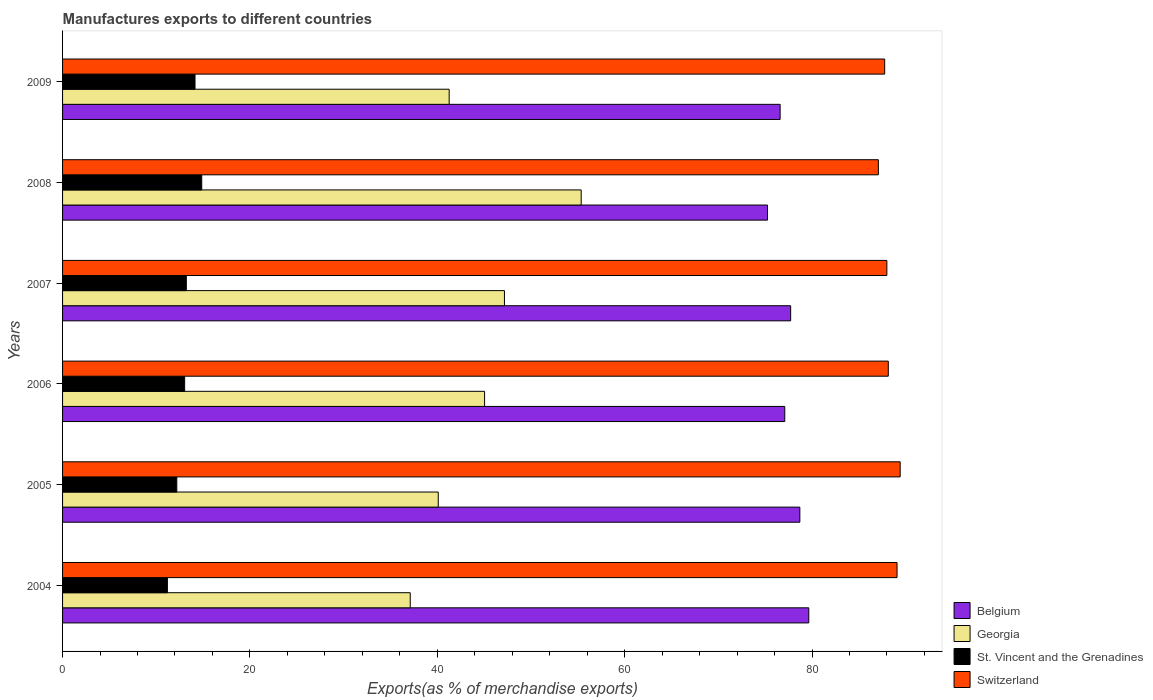How many different coloured bars are there?
Offer a terse response. 4. Are the number of bars on each tick of the Y-axis equal?
Offer a very short reply. Yes. How many bars are there on the 3rd tick from the bottom?
Provide a succinct answer. 4. What is the label of the 6th group of bars from the top?
Provide a short and direct response. 2004. What is the percentage of exports to different countries in St. Vincent and the Grenadines in 2005?
Ensure brevity in your answer.  12.19. Across all years, what is the maximum percentage of exports to different countries in Belgium?
Keep it short and to the point. 79.65. Across all years, what is the minimum percentage of exports to different countries in St. Vincent and the Grenadines?
Provide a succinct answer. 11.19. In which year was the percentage of exports to different countries in Georgia maximum?
Offer a very short reply. 2008. In which year was the percentage of exports to different countries in Georgia minimum?
Keep it short and to the point. 2004. What is the total percentage of exports to different countries in Georgia in the graph?
Give a very brief answer. 266.05. What is the difference between the percentage of exports to different countries in Georgia in 2006 and that in 2009?
Give a very brief answer. 3.78. What is the difference between the percentage of exports to different countries in Switzerland in 2006 and the percentage of exports to different countries in St. Vincent and the Grenadines in 2005?
Offer a terse response. 75.95. What is the average percentage of exports to different countries in Georgia per year?
Offer a terse response. 44.34. In the year 2009, what is the difference between the percentage of exports to different countries in Belgium and percentage of exports to different countries in Georgia?
Make the answer very short. 35.33. What is the ratio of the percentage of exports to different countries in Georgia in 2005 to that in 2009?
Keep it short and to the point. 0.97. Is the percentage of exports to different countries in Georgia in 2005 less than that in 2009?
Keep it short and to the point. Yes. What is the difference between the highest and the second highest percentage of exports to different countries in Belgium?
Make the answer very short. 0.95. What is the difference between the highest and the lowest percentage of exports to different countries in St. Vincent and the Grenadines?
Offer a very short reply. 3.67. Is it the case that in every year, the sum of the percentage of exports to different countries in Switzerland and percentage of exports to different countries in Georgia is greater than the sum of percentage of exports to different countries in St. Vincent and the Grenadines and percentage of exports to different countries in Belgium?
Keep it short and to the point. Yes. What does the 1st bar from the top in 2009 represents?
Your response must be concise. Switzerland. What does the 3rd bar from the bottom in 2006 represents?
Your response must be concise. St. Vincent and the Grenadines. Is it the case that in every year, the sum of the percentage of exports to different countries in Georgia and percentage of exports to different countries in Belgium is greater than the percentage of exports to different countries in St. Vincent and the Grenadines?
Give a very brief answer. Yes. How many bars are there?
Your response must be concise. 24. Are all the bars in the graph horizontal?
Offer a terse response. Yes. How many years are there in the graph?
Your answer should be very brief. 6. Does the graph contain grids?
Provide a succinct answer. No. What is the title of the graph?
Your answer should be compact. Manufactures exports to different countries. What is the label or title of the X-axis?
Give a very brief answer. Exports(as % of merchandise exports). What is the label or title of the Y-axis?
Your answer should be very brief. Years. What is the Exports(as % of merchandise exports) of Belgium in 2004?
Keep it short and to the point. 79.65. What is the Exports(as % of merchandise exports) of Georgia in 2004?
Ensure brevity in your answer.  37.11. What is the Exports(as % of merchandise exports) in St. Vincent and the Grenadines in 2004?
Your answer should be compact. 11.19. What is the Exports(as % of merchandise exports) in Switzerland in 2004?
Your answer should be compact. 89.07. What is the Exports(as % of merchandise exports) of Belgium in 2005?
Your answer should be very brief. 78.7. What is the Exports(as % of merchandise exports) in Georgia in 2005?
Your response must be concise. 40.1. What is the Exports(as % of merchandise exports) in St. Vincent and the Grenadines in 2005?
Your answer should be compact. 12.19. What is the Exports(as % of merchandise exports) in Switzerland in 2005?
Provide a short and direct response. 89.41. What is the Exports(as % of merchandise exports) in Belgium in 2006?
Your answer should be very brief. 77.09. What is the Exports(as % of merchandise exports) of Georgia in 2006?
Offer a terse response. 45.05. What is the Exports(as % of merchandise exports) in St. Vincent and the Grenadines in 2006?
Ensure brevity in your answer.  13.03. What is the Exports(as % of merchandise exports) of Switzerland in 2006?
Keep it short and to the point. 88.14. What is the Exports(as % of merchandise exports) of Belgium in 2007?
Offer a very short reply. 77.72. What is the Exports(as % of merchandise exports) in Georgia in 2007?
Offer a very short reply. 47.17. What is the Exports(as % of merchandise exports) in St. Vincent and the Grenadines in 2007?
Give a very brief answer. 13.21. What is the Exports(as % of merchandise exports) in Switzerland in 2007?
Provide a short and direct response. 87.99. What is the Exports(as % of merchandise exports) of Belgium in 2008?
Make the answer very short. 75.25. What is the Exports(as % of merchandise exports) in Georgia in 2008?
Keep it short and to the point. 55.36. What is the Exports(as % of merchandise exports) in St. Vincent and the Grenadines in 2008?
Your answer should be compact. 14.85. What is the Exports(as % of merchandise exports) in Switzerland in 2008?
Your answer should be compact. 87.08. What is the Exports(as % of merchandise exports) of Belgium in 2009?
Your answer should be compact. 76.59. What is the Exports(as % of merchandise exports) of Georgia in 2009?
Your response must be concise. 41.27. What is the Exports(as % of merchandise exports) of St. Vincent and the Grenadines in 2009?
Keep it short and to the point. 14.14. What is the Exports(as % of merchandise exports) in Switzerland in 2009?
Provide a succinct answer. 87.75. Across all years, what is the maximum Exports(as % of merchandise exports) of Belgium?
Offer a very short reply. 79.65. Across all years, what is the maximum Exports(as % of merchandise exports) of Georgia?
Your response must be concise. 55.36. Across all years, what is the maximum Exports(as % of merchandise exports) in St. Vincent and the Grenadines?
Keep it short and to the point. 14.85. Across all years, what is the maximum Exports(as % of merchandise exports) of Switzerland?
Offer a terse response. 89.41. Across all years, what is the minimum Exports(as % of merchandise exports) in Belgium?
Your response must be concise. 75.25. Across all years, what is the minimum Exports(as % of merchandise exports) of Georgia?
Offer a terse response. 37.11. Across all years, what is the minimum Exports(as % of merchandise exports) of St. Vincent and the Grenadines?
Offer a very short reply. 11.19. Across all years, what is the minimum Exports(as % of merchandise exports) of Switzerland?
Make the answer very short. 87.08. What is the total Exports(as % of merchandise exports) in Belgium in the graph?
Your response must be concise. 465. What is the total Exports(as % of merchandise exports) in Georgia in the graph?
Provide a short and direct response. 266.05. What is the total Exports(as % of merchandise exports) of St. Vincent and the Grenadines in the graph?
Make the answer very short. 78.62. What is the total Exports(as % of merchandise exports) in Switzerland in the graph?
Give a very brief answer. 529.44. What is the difference between the Exports(as % of merchandise exports) of Belgium in 2004 and that in 2005?
Provide a succinct answer. 0.95. What is the difference between the Exports(as % of merchandise exports) of Georgia in 2004 and that in 2005?
Keep it short and to the point. -2.99. What is the difference between the Exports(as % of merchandise exports) in St. Vincent and the Grenadines in 2004 and that in 2005?
Provide a succinct answer. -1. What is the difference between the Exports(as % of merchandise exports) of Switzerland in 2004 and that in 2005?
Offer a terse response. -0.33. What is the difference between the Exports(as % of merchandise exports) of Belgium in 2004 and that in 2006?
Offer a very short reply. 2.56. What is the difference between the Exports(as % of merchandise exports) in Georgia in 2004 and that in 2006?
Make the answer very short. -7.94. What is the difference between the Exports(as % of merchandise exports) of St. Vincent and the Grenadines in 2004 and that in 2006?
Your response must be concise. -1.84. What is the difference between the Exports(as % of merchandise exports) of Switzerland in 2004 and that in 2006?
Provide a short and direct response. 0.93. What is the difference between the Exports(as % of merchandise exports) in Belgium in 2004 and that in 2007?
Your answer should be compact. 1.94. What is the difference between the Exports(as % of merchandise exports) of Georgia in 2004 and that in 2007?
Ensure brevity in your answer.  -10.06. What is the difference between the Exports(as % of merchandise exports) in St. Vincent and the Grenadines in 2004 and that in 2007?
Your response must be concise. -2.02. What is the difference between the Exports(as % of merchandise exports) in Switzerland in 2004 and that in 2007?
Provide a short and direct response. 1.09. What is the difference between the Exports(as % of merchandise exports) of Belgium in 2004 and that in 2008?
Offer a very short reply. 4.41. What is the difference between the Exports(as % of merchandise exports) of Georgia in 2004 and that in 2008?
Provide a short and direct response. -18.25. What is the difference between the Exports(as % of merchandise exports) in St. Vincent and the Grenadines in 2004 and that in 2008?
Ensure brevity in your answer.  -3.67. What is the difference between the Exports(as % of merchandise exports) of Switzerland in 2004 and that in 2008?
Keep it short and to the point. 1.99. What is the difference between the Exports(as % of merchandise exports) in Belgium in 2004 and that in 2009?
Offer a very short reply. 3.06. What is the difference between the Exports(as % of merchandise exports) in Georgia in 2004 and that in 2009?
Offer a very short reply. -4.16. What is the difference between the Exports(as % of merchandise exports) of St. Vincent and the Grenadines in 2004 and that in 2009?
Offer a very short reply. -2.95. What is the difference between the Exports(as % of merchandise exports) of Switzerland in 2004 and that in 2009?
Offer a very short reply. 1.32. What is the difference between the Exports(as % of merchandise exports) in Belgium in 2005 and that in 2006?
Offer a very short reply. 1.61. What is the difference between the Exports(as % of merchandise exports) in Georgia in 2005 and that in 2006?
Offer a very short reply. -4.95. What is the difference between the Exports(as % of merchandise exports) in St. Vincent and the Grenadines in 2005 and that in 2006?
Provide a succinct answer. -0.84. What is the difference between the Exports(as % of merchandise exports) of Switzerland in 2005 and that in 2006?
Your response must be concise. 1.27. What is the difference between the Exports(as % of merchandise exports) of Belgium in 2005 and that in 2007?
Provide a short and direct response. 0.98. What is the difference between the Exports(as % of merchandise exports) of Georgia in 2005 and that in 2007?
Make the answer very short. -7.07. What is the difference between the Exports(as % of merchandise exports) in St. Vincent and the Grenadines in 2005 and that in 2007?
Offer a very short reply. -1.02. What is the difference between the Exports(as % of merchandise exports) of Switzerland in 2005 and that in 2007?
Ensure brevity in your answer.  1.42. What is the difference between the Exports(as % of merchandise exports) of Belgium in 2005 and that in 2008?
Offer a terse response. 3.45. What is the difference between the Exports(as % of merchandise exports) in Georgia in 2005 and that in 2008?
Your answer should be very brief. -15.26. What is the difference between the Exports(as % of merchandise exports) of St. Vincent and the Grenadines in 2005 and that in 2008?
Provide a succinct answer. -2.66. What is the difference between the Exports(as % of merchandise exports) in Switzerland in 2005 and that in 2008?
Offer a terse response. 2.33. What is the difference between the Exports(as % of merchandise exports) of Belgium in 2005 and that in 2009?
Offer a very short reply. 2.11. What is the difference between the Exports(as % of merchandise exports) in Georgia in 2005 and that in 2009?
Your response must be concise. -1.17. What is the difference between the Exports(as % of merchandise exports) of St. Vincent and the Grenadines in 2005 and that in 2009?
Provide a short and direct response. -1.94. What is the difference between the Exports(as % of merchandise exports) of Switzerland in 2005 and that in 2009?
Give a very brief answer. 1.65. What is the difference between the Exports(as % of merchandise exports) of Belgium in 2006 and that in 2007?
Offer a terse response. -0.63. What is the difference between the Exports(as % of merchandise exports) of Georgia in 2006 and that in 2007?
Give a very brief answer. -2.12. What is the difference between the Exports(as % of merchandise exports) of St. Vincent and the Grenadines in 2006 and that in 2007?
Keep it short and to the point. -0.18. What is the difference between the Exports(as % of merchandise exports) of Switzerland in 2006 and that in 2007?
Provide a short and direct response. 0.15. What is the difference between the Exports(as % of merchandise exports) of Belgium in 2006 and that in 2008?
Keep it short and to the point. 1.84. What is the difference between the Exports(as % of merchandise exports) of Georgia in 2006 and that in 2008?
Your answer should be compact. -10.31. What is the difference between the Exports(as % of merchandise exports) of St. Vincent and the Grenadines in 2006 and that in 2008?
Offer a terse response. -1.82. What is the difference between the Exports(as % of merchandise exports) in Switzerland in 2006 and that in 2008?
Give a very brief answer. 1.06. What is the difference between the Exports(as % of merchandise exports) of Belgium in 2006 and that in 2009?
Provide a short and direct response. 0.5. What is the difference between the Exports(as % of merchandise exports) in Georgia in 2006 and that in 2009?
Your answer should be compact. 3.78. What is the difference between the Exports(as % of merchandise exports) in St. Vincent and the Grenadines in 2006 and that in 2009?
Ensure brevity in your answer.  -1.11. What is the difference between the Exports(as % of merchandise exports) in Switzerland in 2006 and that in 2009?
Keep it short and to the point. 0.39. What is the difference between the Exports(as % of merchandise exports) in Belgium in 2007 and that in 2008?
Your answer should be compact. 2.47. What is the difference between the Exports(as % of merchandise exports) in Georgia in 2007 and that in 2008?
Make the answer very short. -8.19. What is the difference between the Exports(as % of merchandise exports) of St. Vincent and the Grenadines in 2007 and that in 2008?
Give a very brief answer. -1.64. What is the difference between the Exports(as % of merchandise exports) of Switzerland in 2007 and that in 2008?
Make the answer very short. 0.91. What is the difference between the Exports(as % of merchandise exports) of Belgium in 2007 and that in 2009?
Provide a short and direct response. 1.12. What is the difference between the Exports(as % of merchandise exports) of Georgia in 2007 and that in 2009?
Ensure brevity in your answer.  5.9. What is the difference between the Exports(as % of merchandise exports) in St. Vincent and the Grenadines in 2007 and that in 2009?
Give a very brief answer. -0.93. What is the difference between the Exports(as % of merchandise exports) in Switzerland in 2007 and that in 2009?
Provide a succinct answer. 0.23. What is the difference between the Exports(as % of merchandise exports) of Belgium in 2008 and that in 2009?
Provide a succinct answer. -1.35. What is the difference between the Exports(as % of merchandise exports) of Georgia in 2008 and that in 2009?
Offer a very short reply. 14.09. What is the difference between the Exports(as % of merchandise exports) in St. Vincent and the Grenadines in 2008 and that in 2009?
Ensure brevity in your answer.  0.72. What is the difference between the Exports(as % of merchandise exports) of Switzerland in 2008 and that in 2009?
Give a very brief answer. -0.67. What is the difference between the Exports(as % of merchandise exports) in Belgium in 2004 and the Exports(as % of merchandise exports) in Georgia in 2005?
Your answer should be compact. 39.55. What is the difference between the Exports(as % of merchandise exports) of Belgium in 2004 and the Exports(as % of merchandise exports) of St. Vincent and the Grenadines in 2005?
Keep it short and to the point. 67.46. What is the difference between the Exports(as % of merchandise exports) in Belgium in 2004 and the Exports(as % of merchandise exports) in Switzerland in 2005?
Keep it short and to the point. -9.75. What is the difference between the Exports(as % of merchandise exports) in Georgia in 2004 and the Exports(as % of merchandise exports) in St. Vincent and the Grenadines in 2005?
Ensure brevity in your answer.  24.92. What is the difference between the Exports(as % of merchandise exports) of Georgia in 2004 and the Exports(as % of merchandise exports) of Switzerland in 2005?
Ensure brevity in your answer.  -52.3. What is the difference between the Exports(as % of merchandise exports) in St. Vincent and the Grenadines in 2004 and the Exports(as % of merchandise exports) in Switzerland in 2005?
Ensure brevity in your answer.  -78.22. What is the difference between the Exports(as % of merchandise exports) of Belgium in 2004 and the Exports(as % of merchandise exports) of Georgia in 2006?
Make the answer very short. 34.61. What is the difference between the Exports(as % of merchandise exports) of Belgium in 2004 and the Exports(as % of merchandise exports) of St. Vincent and the Grenadines in 2006?
Give a very brief answer. 66.62. What is the difference between the Exports(as % of merchandise exports) in Belgium in 2004 and the Exports(as % of merchandise exports) in Switzerland in 2006?
Your answer should be very brief. -8.49. What is the difference between the Exports(as % of merchandise exports) of Georgia in 2004 and the Exports(as % of merchandise exports) of St. Vincent and the Grenadines in 2006?
Ensure brevity in your answer.  24.08. What is the difference between the Exports(as % of merchandise exports) in Georgia in 2004 and the Exports(as % of merchandise exports) in Switzerland in 2006?
Offer a terse response. -51.03. What is the difference between the Exports(as % of merchandise exports) in St. Vincent and the Grenadines in 2004 and the Exports(as % of merchandise exports) in Switzerland in 2006?
Offer a very short reply. -76.95. What is the difference between the Exports(as % of merchandise exports) of Belgium in 2004 and the Exports(as % of merchandise exports) of Georgia in 2007?
Your answer should be very brief. 32.48. What is the difference between the Exports(as % of merchandise exports) in Belgium in 2004 and the Exports(as % of merchandise exports) in St. Vincent and the Grenadines in 2007?
Offer a terse response. 66.44. What is the difference between the Exports(as % of merchandise exports) in Belgium in 2004 and the Exports(as % of merchandise exports) in Switzerland in 2007?
Your response must be concise. -8.33. What is the difference between the Exports(as % of merchandise exports) of Georgia in 2004 and the Exports(as % of merchandise exports) of St. Vincent and the Grenadines in 2007?
Your answer should be compact. 23.9. What is the difference between the Exports(as % of merchandise exports) of Georgia in 2004 and the Exports(as % of merchandise exports) of Switzerland in 2007?
Your answer should be very brief. -50.88. What is the difference between the Exports(as % of merchandise exports) of St. Vincent and the Grenadines in 2004 and the Exports(as % of merchandise exports) of Switzerland in 2007?
Make the answer very short. -76.8. What is the difference between the Exports(as % of merchandise exports) of Belgium in 2004 and the Exports(as % of merchandise exports) of Georgia in 2008?
Keep it short and to the point. 24.29. What is the difference between the Exports(as % of merchandise exports) in Belgium in 2004 and the Exports(as % of merchandise exports) in St. Vincent and the Grenadines in 2008?
Your answer should be very brief. 64.8. What is the difference between the Exports(as % of merchandise exports) of Belgium in 2004 and the Exports(as % of merchandise exports) of Switzerland in 2008?
Your answer should be very brief. -7.43. What is the difference between the Exports(as % of merchandise exports) of Georgia in 2004 and the Exports(as % of merchandise exports) of St. Vincent and the Grenadines in 2008?
Ensure brevity in your answer.  22.26. What is the difference between the Exports(as % of merchandise exports) in Georgia in 2004 and the Exports(as % of merchandise exports) in Switzerland in 2008?
Make the answer very short. -49.97. What is the difference between the Exports(as % of merchandise exports) in St. Vincent and the Grenadines in 2004 and the Exports(as % of merchandise exports) in Switzerland in 2008?
Provide a short and direct response. -75.89. What is the difference between the Exports(as % of merchandise exports) in Belgium in 2004 and the Exports(as % of merchandise exports) in Georgia in 2009?
Make the answer very short. 38.39. What is the difference between the Exports(as % of merchandise exports) of Belgium in 2004 and the Exports(as % of merchandise exports) of St. Vincent and the Grenadines in 2009?
Give a very brief answer. 65.52. What is the difference between the Exports(as % of merchandise exports) in Belgium in 2004 and the Exports(as % of merchandise exports) in Switzerland in 2009?
Your answer should be very brief. -8.1. What is the difference between the Exports(as % of merchandise exports) in Georgia in 2004 and the Exports(as % of merchandise exports) in St. Vincent and the Grenadines in 2009?
Your answer should be compact. 22.97. What is the difference between the Exports(as % of merchandise exports) of Georgia in 2004 and the Exports(as % of merchandise exports) of Switzerland in 2009?
Ensure brevity in your answer.  -50.64. What is the difference between the Exports(as % of merchandise exports) of St. Vincent and the Grenadines in 2004 and the Exports(as % of merchandise exports) of Switzerland in 2009?
Offer a very short reply. -76.57. What is the difference between the Exports(as % of merchandise exports) in Belgium in 2005 and the Exports(as % of merchandise exports) in Georgia in 2006?
Keep it short and to the point. 33.65. What is the difference between the Exports(as % of merchandise exports) in Belgium in 2005 and the Exports(as % of merchandise exports) in St. Vincent and the Grenadines in 2006?
Offer a terse response. 65.67. What is the difference between the Exports(as % of merchandise exports) of Belgium in 2005 and the Exports(as % of merchandise exports) of Switzerland in 2006?
Offer a very short reply. -9.44. What is the difference between the Exports(as % of merchandise exports) in Georgia in 2005 and the Exports(as % of merchandise exports) in St. Vincent and the Grenadines in 2006?
Provide a short and direct response. 27.07. What is the difference between the Exports(as % of merchandise exports) of Georgia in 2005 and the Exports(as % of merchandise exports) of Switzerland in 2006?
Your answer should be compact. -48.04. What is the difference between the Exports(as % of merchandise exports) in St. Vincent and the Grenadines in 2005 and the Exports(as % of merchandise exports) in Switzerland in 2006?
Offer a very short reply. -75.95. What is the difference between the Exports(as % of merchandise exports) in Belgium in 2005 and the Exports(as % of merchandise exports) in Georgia in 2007?
Offer a very short reply. 31.53. What is the difference between the Exports(as % of merchandise exports) in Belgium in 2005 and the Exports(as % of merchandise exports) in St. Vincent and the Grenadines in 2007?
Give a very brief answer. 65.49. What is the difference between the Exports(as % of merchandise exports) of Belgium in 2005 and the Exports(as % of merchandise exports) of Switzerland in 2007?
Keep it short and to the point. -9.29. What is the difference between the Exports(as % of merchandise exports) of Georgia in 2005 and the Exports(as % of merchandise exports) of St. Vincent and the Grenadines in 2007?
Provide a succinct answer. 26.89. What is the difference between the Exports(as % of merchandise exports) in Georgia in 2005 and the Exports(as % of merchandise exports) in Switzerland in 2007?
Your response must be concise. -47.88. What is the difference between the Exports(as % of merchandise exports) of St. Vincent and the Grenadines in 2005 and the Exports(as % of merchandise exports) of Switzerland in 2007?
Offer a terse response. -75.79. What is the difference between the Exports(as % of merchandise exports) of Belgium in 2005 and the Exports(as % of merchandise exports) of Georgia in 2008?
Give a very brief answer. 23.34. What is the difference between the Exports(as % of merchandise exports) in Belgium in 2005 and the Exports(as % of merchandise exports) in St. Vincent and the Grenadines in 2008?
Give a very brief answer. 63.84. What is the difference between the Exports(as % of merchandise exports) of Belgium in 2005 and the Exports(as % of merchandise exports) of Switzerland in 2008?
Give a very brief answer. -8.38. What is the difference between the Exports(as % of merchandise exports) of Georgia in 2005 and the Exports(as % of merchandise exports) of St. Vincent and the Grenadines in 2008?
Make the answer very short. 25.25. What is the difference between the Exports(as % of merchandise exports) in Georgia in 2005 and the Exports(as % of merchandise exports) in Switzerland in 2008?
Make the answer very short. -46.98. What is the difference between the Exports(as % of merchandise exports) of St. Vincent and the Grenadines in 2005 and the Exports(as % of merchandise exports) of Switzerland in 2008?
Offer a very short reply. -74.89. What is the difference between the Exports(as % of merchandise exports) in Belgium in 2005 and the Exports(as % of merchandise exports) in Georgia in 2009?
Your answer should be very brief. 37.43. What is the difference between the Exports(as % of merchandise exports) of Belgium in 2005 and the Exports(as % of merchandise exports) of St. Vincent and the Grenadines in 2009?
Your answer should be compact. 64.56. What is the difference between the Exports(as % of merchandise exports) in Belgium in 2005 and the Exports(as % of merchandise exports) in Switzerland in 2009?
Offer a very short reply. -9.06. What is the difference between the Exports(as % of merchandise exports) of Georgia in 2005 and the Exports(as % of merchandise exports) of St. Vincent and the Grenadines in 2009?
Offer a very short reply. 25.96. What is the difference between the Exports(as % of merchandise exports) in Georgia in 2005 and the Exports(as % of merchandise exports) in Switzerland in 2009?
Your answer should be compact. -47.65. What is the difference between the Exports(as % of merchandise exports) of St. Vincent and the Grenadines in 2005 and the Exports(as % of merchandise exports) of Switzerland in 2009?
Provide a succinct answer. -75.56. What is the difference between the Exports(as % of merchandise exports) of Belgium in 2006 and the Exports(as % of merchandise exports) of Georgia in 2007?
Your answer should be compact. 29.92. What is the difference between the Exports(as % of merchandise exports) in Belgium in 2006 and the Exports(as % of merchandise exports) in St. Vincent and the Grenadines in 2007?
Provide a short and direct response. 63.88. What is the difference between the Exports(as % of merchandise exports) of Belgium in 2006 and the Exports(as % of merchandise exports) of Switzerland in 2007?
Provide a succinct answer. -10.9. What is the difference between the Exports(as % of merchandise exports) of Georgia in 2006 and the Exports(as % of merchandise exports) of St. Vincent and the Grenadines in 2007?
Ensure brevity in your answer.  31.84. What is the difference between the Exports(as % of merchandise exports) of Georgia in 2006 and the Exports(as % of merchandise exports) of Switzerland in 2007?
Provide a succinct answer. -42.94. What is the difference between the Exports(as % of merchandise exports) in St. Vincent and the Grenadines in 2006 and the Exports(as % of merchandise exports) in Switzerland in 2007?
Keep it short and to the point. -74.96. What is the difference between the Exports(as % of merchandise exports) of Belgium in 2006 and the Exports(as % of merchandise exports) of Georgia in 2008?
Offer a very short reply. 21.73. What is the difference between the Exports(as % of merchandise exports) in Belgium in 2006 and the Exports(as % of merchandise exports) in St. Vincent and the Grenadines in 2008?
Offer a very short reply. 62.23. What is the difference between the Exports(as % of merchandise exports) in Belgium in 2006 and the Exports(as % of merchandise exports) in Switzerland in 2008?
Give a very brief answer. -9.99. What is the difference between the Exports(as % of merchandise exports) in Georgia in 2006 and the Exports(as % of merchandise exports) in St. Vincent and the Grenadines in 2008?
Offer a terse response. 30.19. What is the difference between the Exports(as % of merchandise exports) in Georgia in 2006 and the Exports(as % of merchandise exports) in Switzerland in 2008?
Offer a terse response. -42.03. What is the difference between the Exports(as % of merchandise exports) of St. Vincent and the Grenadines in 2006 and the Exports(as % of merchandise exports) of Switzerland in 2008?
Provide a short and direct response. -74.05. What is the difference between the Exports(as % of merchandise exports) in Belgium in 2006 and the Exports(as % of merchandise exports) in Georgia in 2009?
Offer a very short reply. 35.82. What is the difference between the Exports(as % of merchandise exports) in Belgium in 2006 and the Exports(as % of merchandise exports) in St. Vincent and the Grenadines in 2009?
Keep it short and to the point. 62.95. What is the difference between the Exports(as % of merchandise exports) of Belgium in 2006 and the Exports(as % of merchandise exports) of Switzerland in 2009?
Provide a short and direct response. -10.67. What is the difference between the Exports(as % of merchandise exports) of Georgia in 2006 and the Exports(as % of merchandise exports) of St. Vincent and the Grenadines in 2009?
Your answer should be compact. 30.91. What is the difference between the Exports(as % of merchandise exports) in Georgia in 2006 and the Exports(as % of merchandise exports) in Switzerland in 2009?
Give a very brief answer. -42.71. What is the difference between the Exports(as % of merchandise exports) in St. Vincent and the Grenadines in 2006 and the Exports(as % of merchandise exports) in Switzerland in 2009?
Make the answer very short. -74.72. What is the difference between the Exports(as % of merchandise exports) of Belgium in 2007 and the Exports(as % of merchandise exports) of Georgia in 2008?
Offer a terse response. 22.36. What is the difference between the Exports(as % of merchandise exports) of Belgium in 2007 and the Exports(as % of merchandise exports) of St. Vincent and the Grenadines in 2008?
Make the answer very short. 62.86. What is the difference between the Exports(as % of merchandise exports) of Belgium in 2007 and the Exports(as % of merchandise exports) of Switzerland in 2008?
Offer a terse response. -9.36. What is the difference between the Exports(as % of merchandise exports) in Georgia in 2007 and the Exports(as % of merchandise exports) in St. Vincent and the Grenadines in 2008?
Offer a very short reply. 32.31. What is the difference between the Exports(as % of merchandise exports) in Georgia in 2007 and the Exports(as % of merchandise exports) in Switzerland in 2008?
Ensure brevity in your answer.  -39.91. What is the difference between the Exports(as % of merchandise exports) in St. Vincent and the Grenadines in 2007 and the Exports(as % of merchandise exports) in Switzerland in 2008?
Offer a very short reply. -73.87. What is the difference between the Exports(as % of merchandise exports) of Belgium in 2007 and the Exports(as % of merchandise exports) of Georgia in 2009?
Make the answer very short. 36.45. What is the difference between the Exports(as % of merchandise exports) in Belgium in 2007 and the Exports(as % of merchandise exports) in St. Vincent and the Grenadines in 2009?
Keep it short and to the point. 63.58. What is the difference between the Exports(as % of merchandise exports) of Belgium in 2007 and the Exports(as % of merchandise exports) of Switzerland in 2009?
Give a very brief answer. -10.04. What is the difference between the Exports(as % of merchandise exports) in Georgia in 2007 and the Exports(as % of merchandise exports) in St. Vincent and the Grenadines in 2009?
Your answer should be very brief. 33.03. What is the difference between the Exports(as % of merchandise exports) of Georgia in 2007 and the Exports(as % of merchandise exports) of Switzerland in 2009?
Give a very brief answer. -40.59. What is the difference between the Exports(as % of merchandise exports) in St. Vincent and the Grenadines in 2007 and the Exports(as % of merchandise exports) in Switzerland in 2009?
Keep it short and to the point. -74.54. What is the difference between the Exports(as % of merchandise exports) in Belgium in 2008 and the Exports(as % of merchandise exports) in Georgia in 2009?
Provide a short and direct response. 33.98. What is the difference between the Exports(as % of merchandise exports) of Belgium in 2008 and the Exports(as % of merchandise exports) of St. Vincent and the Grenadines in 2009?
Provide a short and direct response. 61.11. What is the difference between the Exports(as % of merchandise exports) of Belgium in 2008 and the Exports(as % of merchandise exports) of Switzerland in 2009?
Provide a short and direct response. -12.51. What is the difference between the Exports(as % of merchandise exports) in Georgia in 2008 and the Exports(as % of merchandise exports) in St. Vincent and the Grenadines in 2009?
Your answer should be very brief. 41.22. What is the difference between the Exports(as % of merchandise exports) of Georgia in 2008 and the Exports(as % of merchandise exports) of Switzerland in 2009?
Offer a very short reply. -32.4. What is the difference between the Exports(as % of merchandise exports) of St. Vincent and the Grenadines in 2008 and the Exports(as % of merchandise exports) of Switzerland in 2009?
Make the answer very short. -72.9. What is the average Exports(as % of merchandise exports) of Belgium per year?
Make the answer very short. 77.5. What is the average Exports(as % of merchandise exports) of Georgia per year?
Provide a succinct answer. 44.34. What is the average Exports(as % of merchandise exports) of St. Vincent and the Grenadines per year?
Make the answer very short. 13.1. What is the average Exports(as % of merchandise exports) in Switzerland per year?
Ensure brevity in your answer.  88.24. In the year 2004, what is the difference between the Exports(as % of merchandise exports) of Belgium and Exports(as % of merchandise exports) of Georgia?
Provide a short and direct response. 42.54. In the year 2004, what is the difference between the Exports(as % of merchandise exports) in Belgium and Exports(as % of merchandise exports) in St. Vincent and the Grenadines?
Make the answer very short. 68.46. In the year 2004, what is the difference between the Exports(as % of merchandise exports) of Belgium and Exports(as % of merchandise exports) of Switzerland?
Provide a succinct answer. -9.42. In the year 2004, what is the difference between the Exports(as % of merchandise exports) of Georgia and Exports(as % of merchandise exports) of St. Vincent and the Grenadines?
Offer a very short reply. 25.92. In the year 2004, what is the difference between the Exports(as % of merchandise exports) in Georgia and Exports(as % of merchandise exports) in Switzerland?
Ensure brevity in your answer.  -51.96. In the year 2004, what is the difference between the Exports(as % of merchandise exports) of St. Vincent and the Grenadines and Exports(as % of merchandise exports) of Switzerland?
Your answer should be very brief. -77.88. In the year 2005, what is the difference between the Exports(as % of merchandise exports) of Belgium and Exports(as % of merchandise exports) of Georgia?
Give a very brief answer. 38.6. In the year 2005, what is the difference between the Exports(as % of merchandise exports) in Belgium and Exports(as % of merchandise exports) in St. Vincent and the Grenadines?
Ensure brevity in your answer.  66.5. In the year 2005, what is the difference between the Exports(as % of merchandise exports) of Belgium and Exports(as % of merchandise exports) of Switzerland?
Offer a very short reply. -10.71. In the year 2005, what is the difference between the Exports(as % of merchandise exports) of Georgia and Exports(as % of merchandise exports) of St. Vincent and the Grenadines?
Provide a short and direct response. 27.91. In the year 2005, what is the difference between the Exports(as % of merchandise exports) in Georgia and Exports(as % of merchandise exports) in Switzerland?
Make the answer very short. -49.31. In the year 2005, what is the difference between the Exports(as % of merchandise exports) in St. Vincent and the Grenadines and Exports(as % of merchandise exports) in Switzerland?
Your answer should be very brief. -77.21. In the year 2006, what is the difference between the Exports(as % of merchandise exports) in Belgium and Exports(as % of merchandise exports) in Georgia?
Make the answer very short. 32.04. In the year 2006, what is the difference between the Exports(as % of merchandise exports) of Belgium and Exports(as % of merchandise exports) of St. Vincent and the Grenadines?
Your response must be concise. 64.06. In the year 2006, what is the difference between the Exports(as % of merchandise exports) in Belgium and Exports(as % of merchandise exports) in Switzerland?
Keep it short and to the point. -11.05. In the year 2006, what is the difference between the Exports(as % of merchandise exports) of Georgia and Exports(as % of merchandise exports) of St. Vincent and the Grenadines?
Offer a very short reply. 32.02. In the year 2006, what is the difference between the Exports(as % of merchandise exports) in Georgia and Exports(as % of merchandise exports) in Switzerland?
Provide a short and direct response. -43.09. In the year 2006, what is the difference between the Exports(as % of merchandise exports) in St. Vincent and the Grenadines and Exports(as % of merchandise exports) in Switzerland?
Ensure brevity in your answer.  -75.11. In the year 2007, what is the difference between the Exports(as % of merchandise exports) of Belgium and Exports(as % of merchandise exports) of Georgia?
Offer a very short reply. 30.55. In the year 2007, what is the difference between the Exports(as % of merchandise exports) of Belgium and Exports(as % of merchandise exports) of St. Vincent and the Grenadines?
Your answer should be very brief. 64.51. In the year 2007, what is the difference between the Exports(as % of merchandise exports) in Belgium and Exports(as % of merchandise exports) in Switzerland?
Provide a succinct answer. -10.27. In the year 2007, what is the difference between the Exports(as % of merchandise exports) in Georgia and Exports(as % of merchandise exports) in St. Vincent and the Grenadines?
Ensure brevity in your answer.  33.96. In the year 2007, what is the difference between the Exports(as % of merchandise exports) in Georgia and Exports(as % of merchandise exports) in Switzerland?
Your answer should be very brief. -40.82. In the year 2007, what is the difference between the Exports(as % of merchandise exports) of St. Vincent and the Grenadines and Exports(as % of merchandise exports) of Switzerland?
Ensure brevity in your answer.  -74.77. In the year 2008, what is the difference between the Exports(as % of merchandise exports) of Belgium and Exports(as % of merchandise exports) of Georgia?
Keep it short and to the point. 19.89. In the year 2008, what is the difference between the Exports(as % of merchandise exports) of Belgium and Exports(as % of merchandise exports) of St. Vincent and the Grenadines?
Make the answer very short. 60.39. In the year 2008, what is the difference between the Exports(as % of merchandise exports) in Belgium and Exports(as % of merchandise exports) in Switzerland?
Your answer should be compact. -11.83. In the year 2008, what is the difference between the Exports(as % of merchandise exports) in Georgia and Exports(as % of merchandise exports) in St. Vincent and the Grenadines?
Offer a very short reply. 40.5. In the year 2008, what is the difference between the Exports(as % of merchandise exports) of Georgia and Exports(as % of merchandise exports) of Switzerland?
Keep it short and to the point. -31.72. In the year 2008, what is the difference between the Exports(as % of merchandise exports) in St. Vincent and the Grenadines and Exports(as % of merchandise exports) in Switzerland?
Your answer should be compact. -72.23. In the year 2009, what is the difference between the Exports(as % of merchandise exports) of Belgium and Exports(as % of merchandise exports) of Georgia?
Provide a short and direct response. 35.33. In the year 2009, what is the difference between the Exports(as % of merchandise exports) in Belgium and Exports(as % of merchandise exports) in St. Vincent and the Grenadines?
Provide a short and direct response. 62.46. In the year 2009, what is the difference between the Exports(as % of merchandise exports) of Belgium and Exports(as % of merchandise exports) of Switzerland?
Your answer should be very brief. -11.16. In the year 2009, what is the difference between the Exports(as % of merchandise exports) in Georgia and Exports(as % of merchandise exports) in St. Vincent and the Grenadines?
Offer a terse response. 27.13. In the year 2009, what is the difference between the Exports(as % of merchandise exports) in Georgia and Exports(as % of merchandise exports) in Switzerland?
Your response must be concise. -46.49. In the year 2009, what is the difference between the Exports(as % of merchandise exports) in St. Vincent and the Grenadines and Exports(as % of merchandise exports) in Switzerland?
Provide a succinct answer. -73.62. What is the ratio of the Exports(as % of merchandise exports) of Belgium in 2004 to that in 2005?
Offer a terse response. 1.01. What is the ratio of the Exports(as % of merchandise exports) in Georgia in 2004 to that in 2005?
Make the answer very short. 0.93. What is the ratio of the Exports(as % of merchandise exports) of St. Vincent and the Grenadines in 2004 to that in 2005?
Give a very brief answer. 0.92. What is the ratio of the Exports(as % of merchandise exports) of Switzerland in 2004 to that in 2005?
Provide a succinct answer. 1. What is the ratio of the Exports(as % of merchandise exports) in Belgium in 2004 to that in 2006?
Offer a terse response. 1.03. What is the ratio of the Exports(as % of merchandise exports) of Georgia in 2004 to that in 2006?
Your answer should be compact. 0.82. What is the ratio of the Exports(as % of merchandise exports) in St. Vincent and the Grenadines in 2004 to that in 2006?
Your answer should be very brief. 0.86. What is the ratio of the Exports(as % of merchandise exports) in Switzerland in 2004 to that in 2006?
Provide a succinct answer. 1.01. What is the ratio of the Exports(as % of merchandise exports) of Belgium in 2004 to that in 2007?
Provide a short and direct response. 1.02. What is the ratio of the Exports(as % of merchandise exports) in Georgia in 2004 to that in 2007?
Provide a succinct answer. 0.79. What is the ratio of the Exports(as % of merchandise exports) of St. Vincent and the Grenadines in 2004 to that in 2007?
Your answer should be very brief. 0.85. What is the ratio of the Exports(as % of merchandise exports) of Switzerland in 2004 to that in 2007?
Provide a short and direct response. 1.01. What is the ratio of the Exports(as % of merchandise exports) of Belgium in 2004 to that in 2008?
Offer a terse response. 1.06. What is the ratio of the Exports(as % of merchandise exports) in Georgia in 2004 to that in 2008?
Your answer should be very brief. 0.67. What is the ratio of the Exports(as % of merchandise exports) of St. Vincent and the Grenadines in 2004 to that in 2008?
Keep it short and to the point. 0.75. What is the ratio of the Exports(as % of merchandise exports) in Switzerland in 2004 to that in 2008?
Keep it short and to the point. 1.02. What is the ratio of the Exports(as % of merchandise exports) of Belgium in 2004 to that in 2009?
Ensure brevity in your answer.  1.04. What is the ratio of the Exports(as % of merchandise exports) in Georgia in 2004 to that in 2009?
Provide a short and direct response. 0.9. What is the ratio of the Exports(as % of merchandise exports) in St. Vincent and the Grenadines in 2004 to that in 2009?
Ensure brevity in your answer.  0.79. What is the ratio of the Exports(as % of merchandise exports) of Belgium in 2005 to that in 2006?
Your answer should be compact. 1.02. What is the ratio of the Exports(as % of merchandise exports) of Georgia in 2005 to that in 2006?
Make the answer very short. 0.89. What is the ratio of the Exports(as % of merchandise exports) of St. Vincent and the Grenadines in 2005 to that in 2006?
Your response must be concise. 0.94. What is the ratio of the Exports(as % of merchandise exports) in Switzerland in 2005 to that in 2006?
Offer a terse response. 1.01. What is the ratio of the Exports(as % of merchandise exports) of Belgium in 2005 to that in 2007?
Your response must be concise. 1.01. What is the ratio of the Exports(as % of merchandise exports) in Georgia in 2005 to that in 2007?
Give a very brief answer. 0.85. What is the ratio of the Exports(as % of merchandise exports) in St. Vincent and the Grenadines in 2005 to that in 2007?
Offer a very short reply. 0.92. What is the ratio of the Exports(as % of merchandise exports) of Switzerland in 2005 to that in 2007?
Provide a succinct answer. 1.02. What is the ratio of the Exports(as % of merchandise exports) of Belgium in 2005 to that in 2008?
Offer a very short reply. 1.05. What is the ratio of the Exports(as % of merchandise exports) in Georgia in 2005 to that in 2008?
Provide a short and direct response. 0.72. What is the ratio of the Exports(as % of merchandise exports) of St. Vincent and the Grenadines in 2005 to that in 2008?
Make the answer very short. 0.82. What is the ratio of the Exports(as % of merchandise exports) of Switzerland in 2005 to that in 2008?
Offer a terse response. 1.03. What is the ratio of the Exports(as % of merchandise exports) in Belgium in 2005 to that in 2009?
Provide a succinct answer. 1.03. What is the ratio of the Exports(as % of merchandise exports) of Georgia in 2005 to that in 2009?
Provide a succinct answer. 0.97. What is the ratio of the Exports(as % of merchandise exports) in St. Vincent and the Grenadines in 2005 to that in 2009?
Your answer should be very brief. 0.86. What is the ratio of the Exports(as % of merchandise exports) of Switzerland in 2005 to that in 2009?
Offer a very short reply. 1.02. What is the ratio of the Exports(as % of merchandise exports) of Belgium in 2006 to that in 2007?
Your answer should be very brief. 0.99. What is the ratio of the Exports(as % of merchandise exports) of Georgia in 2006 to that in 2007?
Make the answer very short. 0.95. What is the ratio of the Exports(as % of merchandise exports) in St. Vincent and the Grenadines in 2006 to that in 2007?
Offer a terse response. 0.99. What is the ratio of the Exports(as % of merchandise exports) of Belgium in 2006 to that in 2008?
Ensure brevity in your answer.  1.02. What is the ratio of the Exports(as % of merchandise exports) in Georgia in 2006 to that in 2008?
Your answer should be compact. 0.81. What is the ratio of the Exports(as % of merchandise exports) of St. Vincent and the Grenadines in 2006 to that in 2008?
Ensure brevity in your answer.  0.88. What is the ratio of the Exports(as % of merchandise exports) of Switzerland in 2006 to that in 2008?
Give a very brief answer. 1.01. What is the ratio of the Exports(as % of merchandise exports) in Belgium in 2006 to that in 2009?
Your response must be concise. 1.01. What is the ratio of the Exports(as % of merchandise exports) in Georgia in 2006 to that in 2009?
Provide a succinct answer. 1.09. What is the ratio of the Exports(as % of merchandise exports) in St. Vincent and the Grenadines in 2006 to that in 2009?
Provide a succinct answer. 0.92. What is the ratio of the Exports(as % of merchandise exports) in Belgium in 2007 to that in 2008?
Offer a very short reply. 1.03. What is the ratio of the Exports(as % of merchandise exports) in Georgia in 2007 to that in 2008?
Your answer should be compact. 0.85. What is the ratio of the Exports(as % of merchandise exports) in St. Vincent and the Grenadines in 2007 to that in 2008?
Keep it short and to the point. 0.89. What is the ratio of the Exports(as % of merchandise exports) of Switzerland in 2007 to that in 2008?
Offer a terse response. 1.01. What is the ratio of the Exports(as % of merchandise exports) in Belgium in 2007 to that in 2009?
Provide a short and direct response. 1.01. What is the ratio of the Exports(as % of merchandise exports) of Georgia in 2007 to that in 2009?
Provide a short and direct response. 1.14. What is the ratio of the Exports(as % of merchandise exports) of St. Vincent and the Grenadines in 2007 to that in 2009?
Ensure brevity in your answer.  0.93. What is the ratio of the Exports(as % of merchandise exports) of Belgium in 2008 to that in 2009?
Your response must be concise. 0.98. What is the ratio of the Exports(as % of merchandise exports) of Georgia in 2008 to that in 2009?
Provide a short and direct response. 1.34. What is the ratio of the Exports(as % of merchandise exports) in St. Vincent and the Grenadines in 2008 to that in 2009?
Give a very brief answer. 1.05. What is the difference between the highest and the second highest Exports(as % of merchandise exports) in Belgium?
Ensure brevity in your answer.  0.95. What is the difference between the highest and the second highest Exports(as % of merchandise exports) of Georgia?
Your answer should be compact. 8.19. What is the difference between the highest and the second highest Exports(as % of merchandise exports) in St. Vincent and the Grenadines?
Your answer should be very brief. 0.72. What is the difference between the highest and the second highest Exports(as % of merchandise exports) of Switzerland?
Make the answer very short. 0.33. What is the difference between the highest and the lowest Exports(as % of merchandise exports) in Belgium?
Ensure brevity in your answer.  4.41. What is the difference between the highest and the lowest Exports(as % of merchandise exports) in Georgia?
Offer a terse response. 18.25. What is the difference between the highest and the lowest Exports(as % of merchandise exports) in St. Vincent and the Grenadines?
Provide a succinct answer. 3.67. What is the difference between the highest and the lowest Exports(as % of merchandise exports) of Switzerland?
Provide a succinct answer. 2.33. 